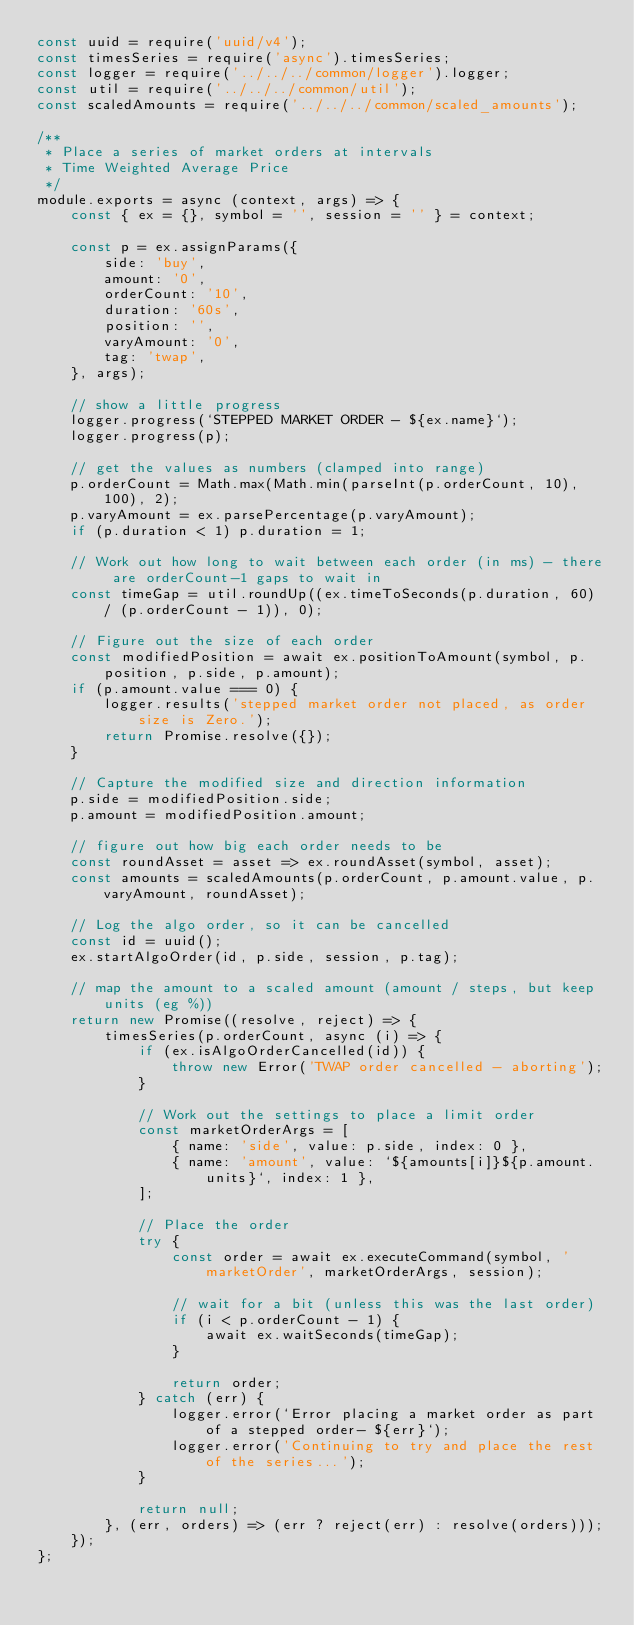<code> <loc_0><loc_0><loc_500><loc_500><_JavaScript_>const uuid = require('uuid/v4');
const timesSeries = require('async').timesSeries;
const logger = require('../../../common/logger').logger;
const util = require('../../../common/util');
const scaledAmounts = require('../../../common/scaled_amounts');

/**
 * Place a series of market orders at intervals
 * Time Weighted Average Price
 */
module.exports = async (context, args) => {
    const { ex = {}, symbol = '', session = '' } = context;

    const p = ex.assignParams({
        side: 'buy',
        amount: '0',
        orderCount: '10',
        duration: '60s',
        position: '',
        varyAmount: '0',
        tag: 'twap',
    }, args);

    // show a little progress
    logger.progress(`STEPPED MARKET ORDER - ${ex.name}`);
    logger.progress(p);

    // get the values as numbers (clamped into range)
    p.orderCount = Math.max(Math.min(parseInt(p.orderCount, 10), 100), 2);
    p.varyAmount = ex.parsePercentage(p.varyAmount);
    if (p.duration < 1) p.duration = 1;

    // Work out how long to wait between each order (in ms) - there are orderCount-1 gaps to wait in
    const timeGap = util.roundUp((ex.timeToSeconds(p.duration, 60) / (p.orderCount - 1)), 0);

    // Figure out the size of each order
    const modifiedPosition = await ex.positionToAmount(symbol, p.position, p.side, p.amount);
    if (p.amount.value === 0) {
        logger.results('stepped market order not placed, as order size is Zero.');
        return Promise.resolve({});
    }

    // Capture the modified size and direction information
    p.side = modifiedPosition.side;
    p.amount = modifiedPosition.amount;

    // figure out how big each order needs to be
    const roundAsset = asset => ex.roundAsset(symbol, asset);
    const amounts = scaledAmounts(p.orderCount, p.amount.value, p.varyAmount, roundAsset);

    // Log the algo order, so it can be cancelled
    const id = uuid();
    ex.startAlgoOrder(id, p.side, session, p.tag);

    // map the amount to a scaled amount (amount / steps, but keep units (eg %))
    return new Promise((resolve, reject) => {
        timesSeries(p.orderCount, async (i) => {
            if (ex.isAlgoOrderCancelled(id)) {
                throw new Error('TWAP order cancelled - aborting');
            }

            // Work out the settings to place a limit order
            const marketOrderArgs = [
                { name: 'side', value: p.side, index: 0 },
                { name: 'amount', value: `${amounts[i]}${p.amount.units}`, index: 1 },
            ];

            // Place the order
            try {
                const order = await ex.executeCommand(symbol, 'marketOrder', marketOrderArgs, session);

                // wait for a bit (unless this was the last order)
                if (i < p.orderCount - 1) {
                    await ex.waitSeconds(timeGap);
                }

                return order;
            } catch (err) {
                logger.error(`Error placing a market order as part of a stepped order- ${err}`);
                logger.error('Continuing to try and place the rest of the series...');
            }

            return null;
        }, (err, orders) => (err ? reject(err) : resolve(orders)));
    });
};
</code> 